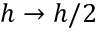Convert formula to latex. <formula><loc_0><loc_0><loc_500><loc_500>h \to h / 2</formula> 